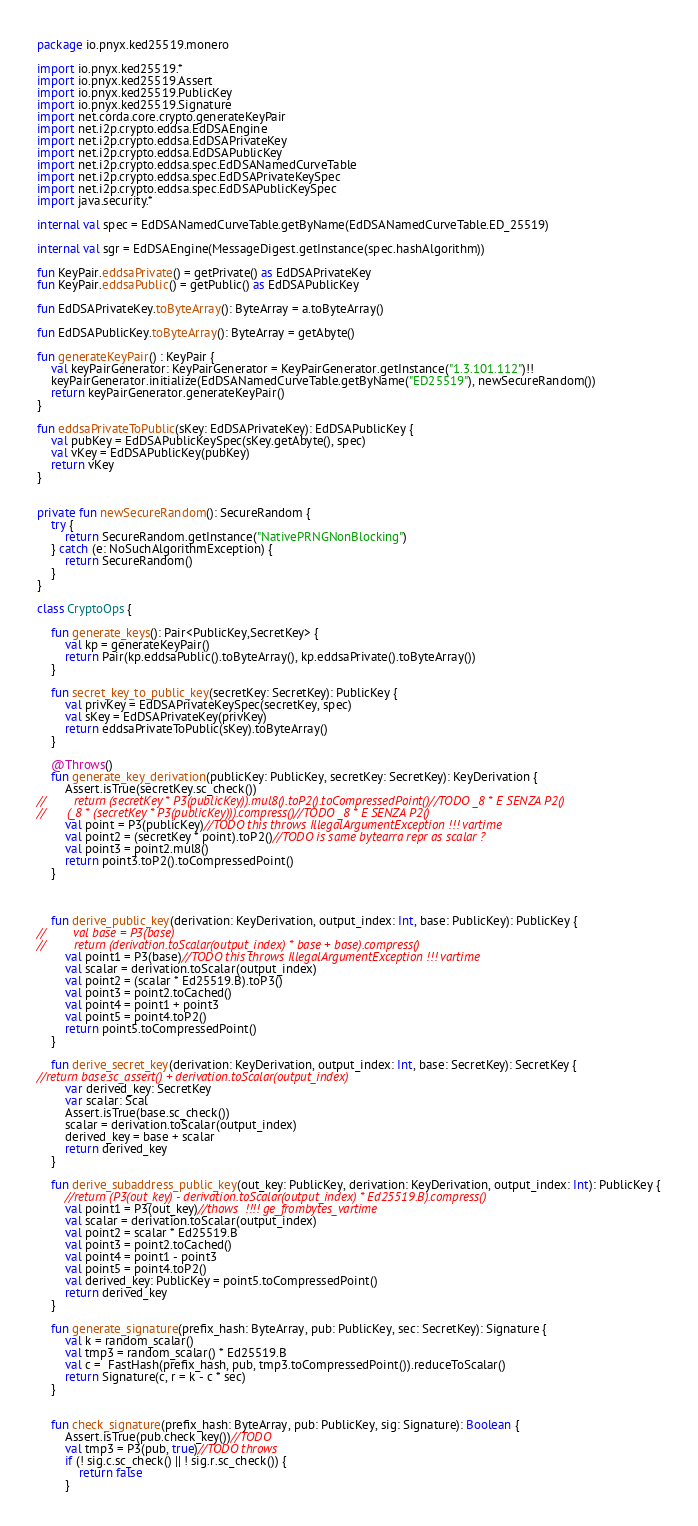Convert code to text. <code><loc_0><loc_0><loc_500><loc_500><_Kotlin_>package io.pnyx.ked25519.monero

import io.pnyx.ked25519.*
import io.pnyx.ked25519.Assert
import io.pnyx.ked25519.PublicKey
import io.pnyx.ked25519.Signature
import net.corda.core.crypto.generateKeyPair
import net.i2p.crypto.eddsa.EdDSAEngine
import net.i2p.crypto.eddsa.EdDSAPrivateKey
import net.i2p.crypto.eddsa.EdDSAPublicKey
import net.i2p.crypto.eddsa.spec.EdDSANamedCurveTable
import net.i2p.crypto.eddsa.spec.EdDSAPrivateKeySpec
import net.i2p.crypto.eddsa.spec.EdDSAPublicKeySpec
import java.security.*

internal val spec = EdDSANamedCurveTable.getByName(EdDSANamedCurveTable.ED_25519)

internal val sgr = EdDSAEngine(MessageDigest.getInstance(spec.hashAlgorithm))

fun KeyPair.eddsaPrivate() = getPrivate() as EdDSAPrivateKey
fun KeyPair.eddsaPublic() = getPublic() as EdDSAPublicKey

fun EdDSAPrivateKey.toByteArray(): ByteArray = a.toByteArray()

fun EdDSAPublicKey.toByteArray(): ByteArray = getAbyte()

fun generateKeyPair() : KeyPair {
    val keyPairGenerator: KeyPairGenerator = KeyPairGenerator.getInstance("1.3.101.112")!!
    keyPairGenerator.initialize(EdDSANamedCurveTable.getByName("ED25519"), newSecureRandom())
    return keyPairGenerator.generateKeyPair()
}

fun eddsaPrivateToPublic(sKey: EdDSAPrivateKey): EdDSAPublicKey {
    val pubKey = EdDSAPublicKeySpec(sKey.getAbyte(), spec)
    val vKey = EdDSAPublicKey(pubKey)
    return vKey
}


private fun newSecureRandom(): SecureRandom {
    try {
        return SecureRandom.getInstance("NativePRNGNonBlocking")
    } catch (e: NoSuchAlgorithmException) {
        return SecureRandom()
    }
}

class CryptoOps {

    fun generate_keys(): Pair<PublicKey,SecretKey> {
        val kp = generateKeyPair()
        return Pair(kp.eddsaPublic().toByteArray(), kp.eddsaPrivate().toByteArray())
    }

    fun secret_key_to_public_key(secretKey: SecretKey): PublicKey {
        val privKey = EdDSAPrivateKeySpec(secretKey, spec)
        val sKey = EdDSAPrivateKey(privKey)
        return eddsaPrivateToPublic(sKey).toByteArray()
    }

    @Throws()
    fun generate_key_derivation(publicKey: PublicKey, secretKey: SecretKey): KeyDerivation {
        Assert.isTrue(secretKey.sc_check())
//        return (secretKey * P3(publicKey)).mul8().toP2().toCompressedPoint()//TODO _8 * E SENZA P2()
//      (_8 * (secretKey * P3(publicKey))).compress()//TODO _8 * E SENZA P2()
        val point = P3(publicKey)//TODO this throws IllegalArgumentException !!! vartime
        val point2 = (secretKey * point).toP2()//TODO is same bytearra repr as scalar ?
        val point3 = point2.mul8()
        return point3.toP2().toCompressedPoint()
    }



    fun derive_public_key(derivation: KeyDerivation, output_index: Int, base: PublicKey): PublicKey {
//        val base = P3(base)
//        return (derivation.toScalar(output_index) * base + base).compress()
        val point1 = P3(base)//TODO this throws IllegalArgumentException !!! vartime
        val scalar = derivation.toScalar(output_index)
        val point2 = (scalar * Ed25519.B).toP3()
        val point3 = point2.toCached()
        val point4 = point1 + point3
        val point5 = point4.toP2()
        return point5.toCompressedPoint()
    }

    fun derive_secret_key(derivation: KeyDerivation, output_index: Int, base: SecretKey): SecretKey {
//return base.sc_assert() + derivation.toScalar(output_index)
        var derived_key: SecretKey
        var scalar: Scal
        Assert.isTrue(base.sc_check())
        scalar = derivation.toScalar(output_index)
        derived_key = base + scalar
        return derived_key
    }

    fun derive_subaddress_public_key(out_key: PublicKey, derivation: KeyDerivation, output_index: Int): PublicKey {
        //return (P3(out_key) - derivation.toScalar(output_index) * Ed25519.B).compress()
        val point1 = P3(out_key)//thows  !!!! ge_frombytes_vartime
        val scalar = derivation.toScalar(output_index)
        val point2 = scalar * Ed25519.B
        val point3 = point2.toCached()
        val point4 = point1 - point3
        val point5 = point4.toP2()
        val derived_key: PublicKey = point5.toCompressedPoint()
        return derived_key
    }

    fun generate_signature(prefix_hash: ByteArray, pub: PublicKey, sec: SecretKey): Signature {
        val k = random_scalar()
        val tmp3 = random_scalar() * Ed25519.B
        val c =  FastHash(prefix_hash, pub, tmp3.toCompressedPoint()).reduceToScalar()
        return Signature(c, r = k - c * sec)
    }


    fun check_signature(prefix_hash: ByteArray, pub: PublicKey, sig: Signature): Boolean {
        Assert.isTrue(pub.check_key())//TODO
        val tmp3 = P3(pub, true)//TODO throws
        if (! sig.c.sc_check() || ! sig.r.sc_check()) {
            return false
        }</code> 